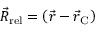<formula> <loc_0><loc_0><loc_500><loc_500>{ \vec { R } _ { r e l } } = \left ( { \vec { r } } - { \vec { r } _ { C } } \right )</formula> 